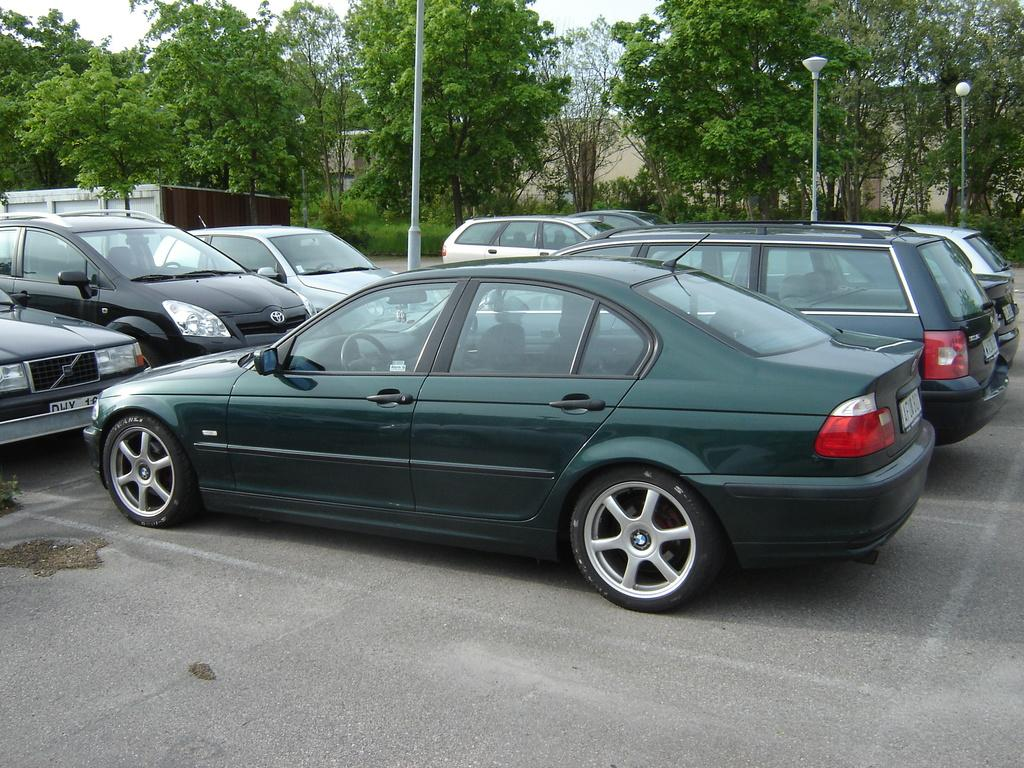Where was the image taken? The image was taken in a parking lot. What can be seen in the parking lot? There are cars in the image. What other objects are present in the parking lot? There are poles in the image. What is visible beyond the parking lot? There is a road, trees, and a building in the background of the image. How much sugar is in the bit of candy that someone is eating in the image? There is no candy or person eating candy present in the image. 